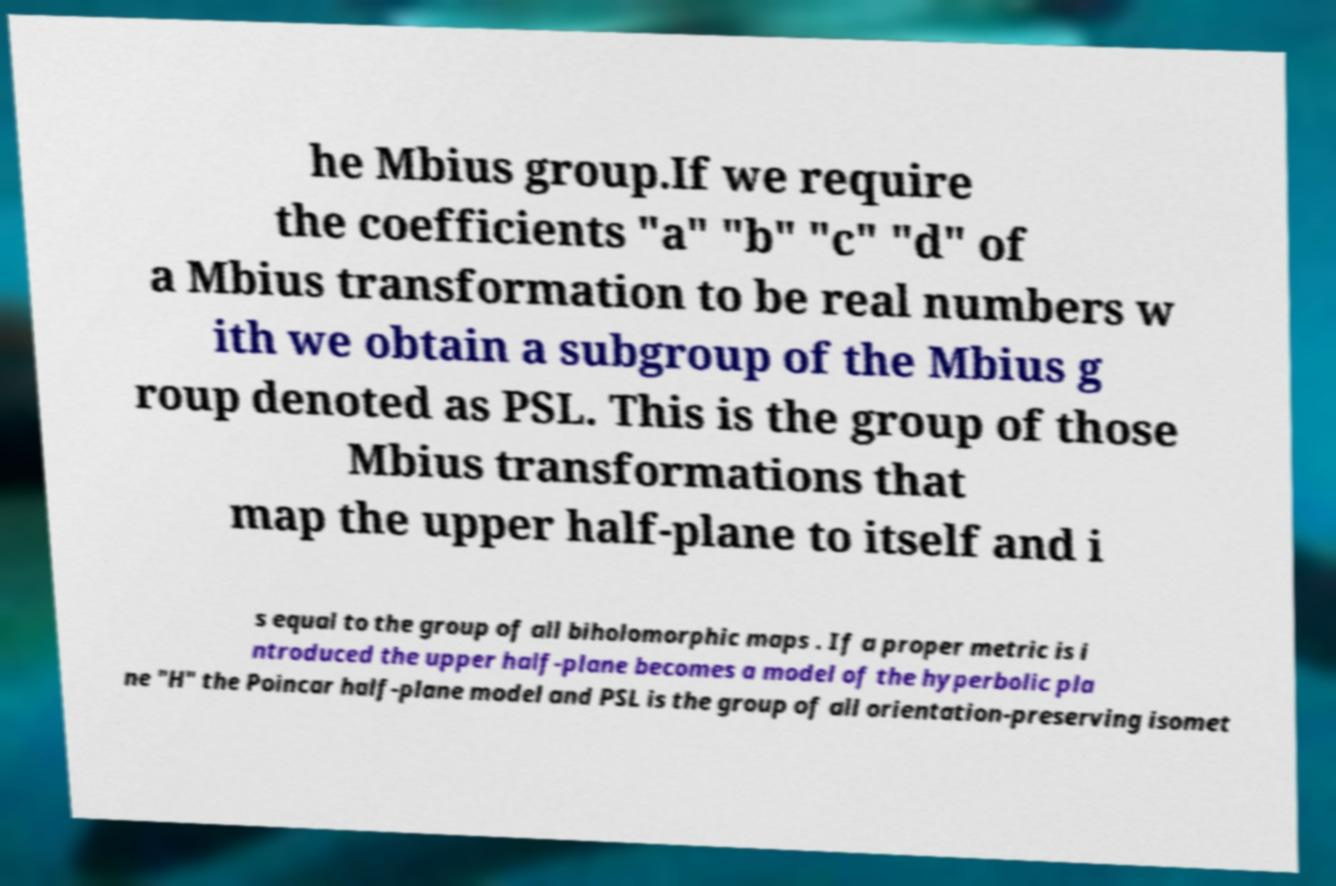Can you read and provide the text displayed in the image?This photo seems to have some interesting text. Can you extract and type it out for me? he Mbius group.If we require the coefficients "a" "b" "c" "d" of a Mbius transformation to be real numbers w ith we obtain a subgroup of the Mbius g roup denoted as PSL. This is the group of those Mbius transformations that map the upper half-plane to itself and i s equal to the group of all biholomorphic maps . If a proper metric is i ntroduced the upper half-plane becomes a model of the hyperbolic pla ne "H" the Poincar half-plane model and PSL is the group of all orientation-preserving isomet 